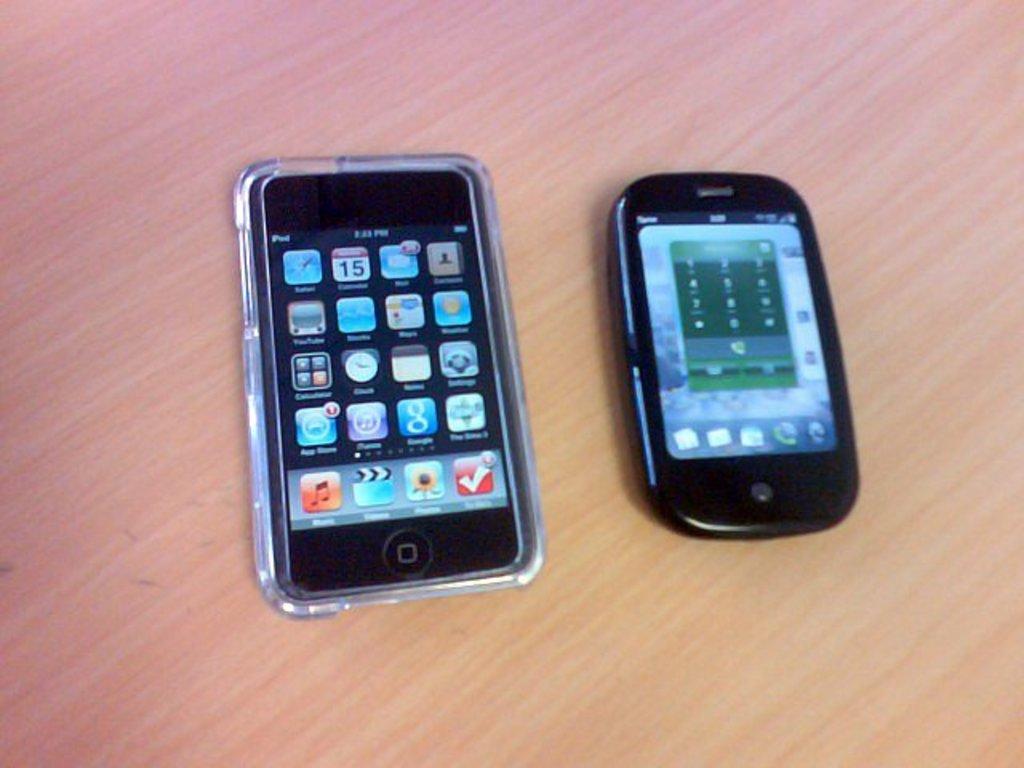What date is on the iphone?
Provide a short and direct response. Unanswerable. What is the first app on the 3rd row on the iphone?
Your response must be concise. Calculator. 